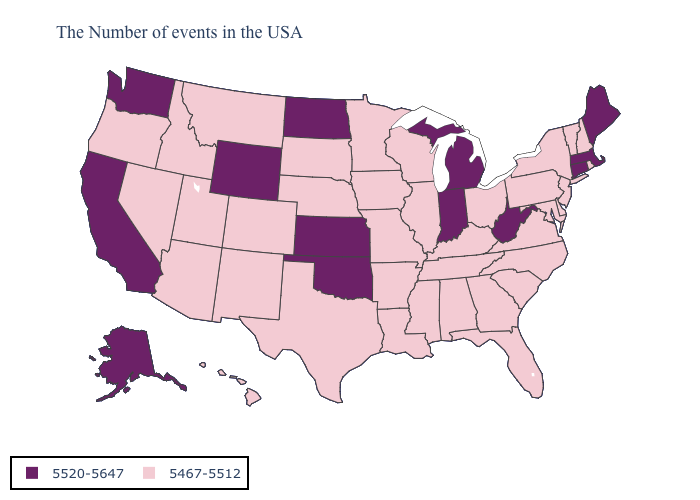Does Oklahoma have the lowest value in the USA?
Be succinct. No. Does the first symbol in the legend represent the smallest category?
Quick response, please. No. Which states hav the highest value in the West?
Keep it brief. Wyoming, California, Washington, Alaska. Name the states that have a value in the range 5520-5647?
Short answer required. Maine, Massachusetts, Connecticut, West Virginia, Michigan, Indiana, Kansas, Oklahoma, North Dakota, Wyoming, California, Washington, Alaska. Which states hav the highest value in the West?
Short answer required. Wyoming, California, Washington, Alaska. Does South Carolina have a lower value than Washington?
Keep it brief. Yes. Is the legend a continuous bar?
Answer briefly. No. Does Kansas have a higher value than Mississippi?
Short answer required. Yes. What is the lowest value in states that border Utah?
Short answer required. 5467-5512. How many symbols are there in the legend?
Concise answer only. 2. What is the lowest value in states that border Iowa?
Be succinct. 5467-5512. Among the states that border Indiana , which have the lowest value?
Keep it brief. Ohio, Kentucky, Illinois. What is the value of Ohio?
Give a very brief answer. 5467-5512. Name the states that have a value in the range 5520-5647?
Keep it brief. Maine, Massachusetts, Connecticut, West Virginia, Michigan, Indiana, Kansas, Oklahoma, North Dakota, Wyoming, California, Washington, Alaska. 